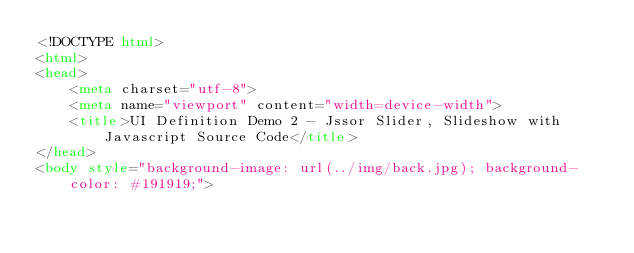Convert code to text. <code><loc_0><loc_0><loc_500><loc_500><_HTML_><!DOCTYPE html>
<html>
<head>
    <meta charset="utf-8">
    <meta name="viewport" content="width=device-width">
    <title>UI Definition Demo 2 - Jssor Slider, Slideshow with Javascript Source Code</title>
</head>
<body style="background-image: url(../img/back.jpg); background-color: #191919;"></code> 